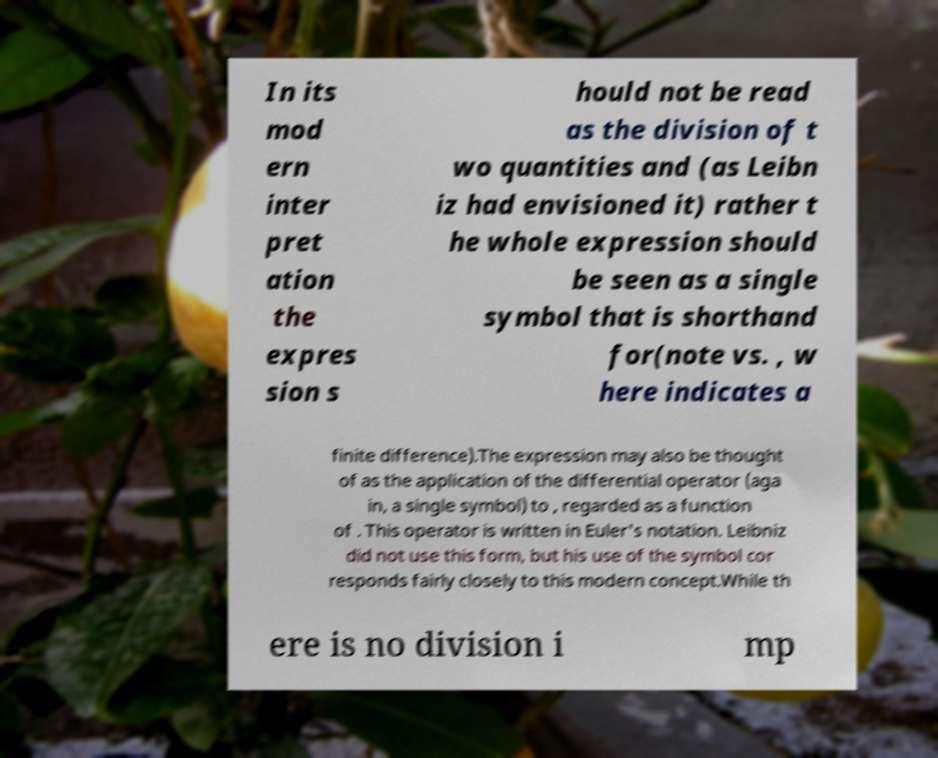Please read and relay the text visible in this image. What does it say? In its mod ern inter pret ation the expres sion s hould not be read as the division of t wo quantities and (as Leibn iz had envisioned it) rather t he whole expression should be seen as a single symbol that is shorthand for(note vs. , w here indicates a finite difference).The expression may also be thought of as the application of the differential operator (aga in, a single symbol) to , regarded as a function of . This operator is written in Euler's notation. Leibniz did not use this form, but his use of the symbol cor responds fairly closely to this modern concept.While th ere is no division i mp 